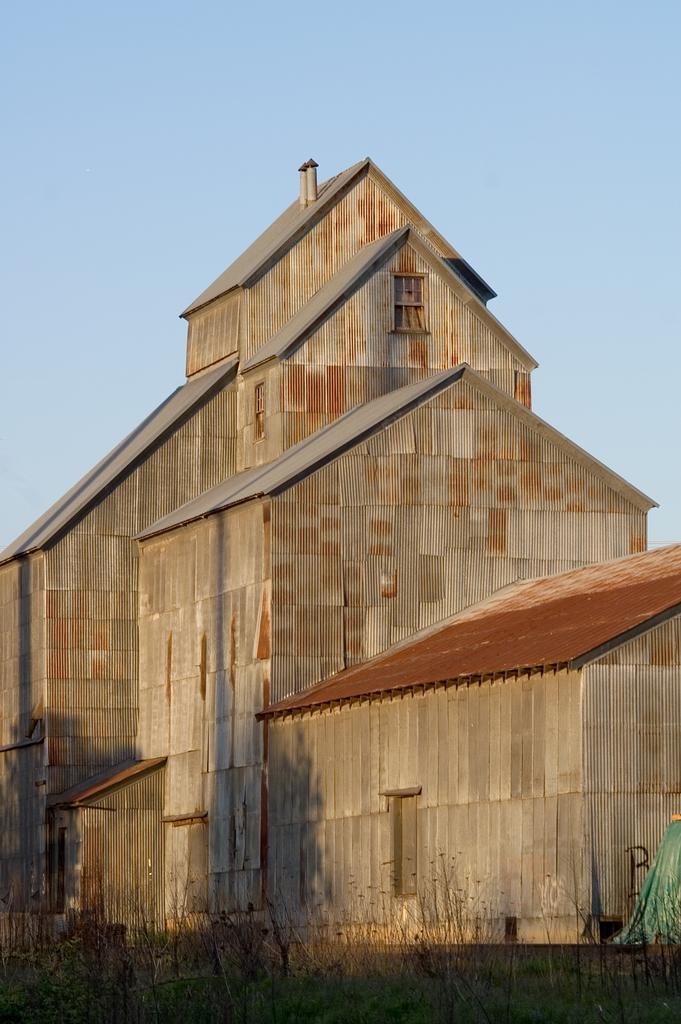What type of structure is visible in the image? There is a building in the image. What can be seen at the bottom of the image? Plants are present at the bottom of the image. What object is located at the right bottom of the image? There is an object at the right bottom of the image. What is visible at the top of the image? The sky is visible at the top of the image. What type of corn is being bitten by the loaf in the image? There is no corn or loaf present in the image. 